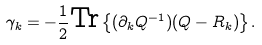Convert formula to latex. <formula><loc_0><loc_0><loc_500><loc_500>\gamma _ { k } = - \frac { 1 } { 2 } \text {Tr} \left \{ ( \partial _ { k } Q ^ { - 1 } ) ( Q - R _ { k } ) \right \} .</formula> 